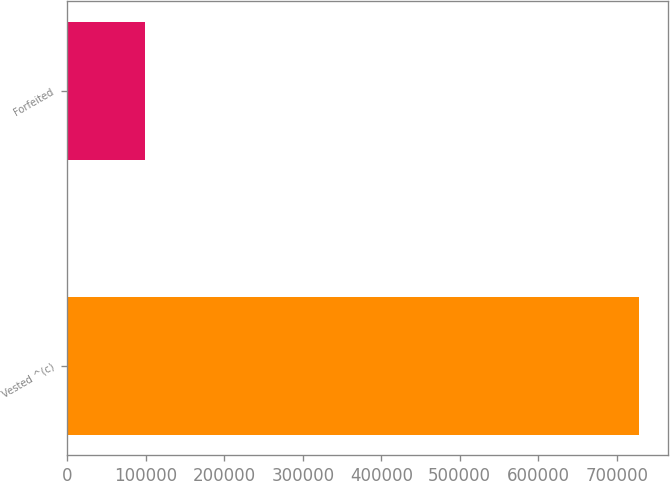Convert chart to OTSL. <chart><loc_0><loc_0><loc_500><loc_500><bar_chart><fcel>Vested ^(c)<fcel>Forfeited<nl><fcel>728576<fcel>98509<nl></chart> 